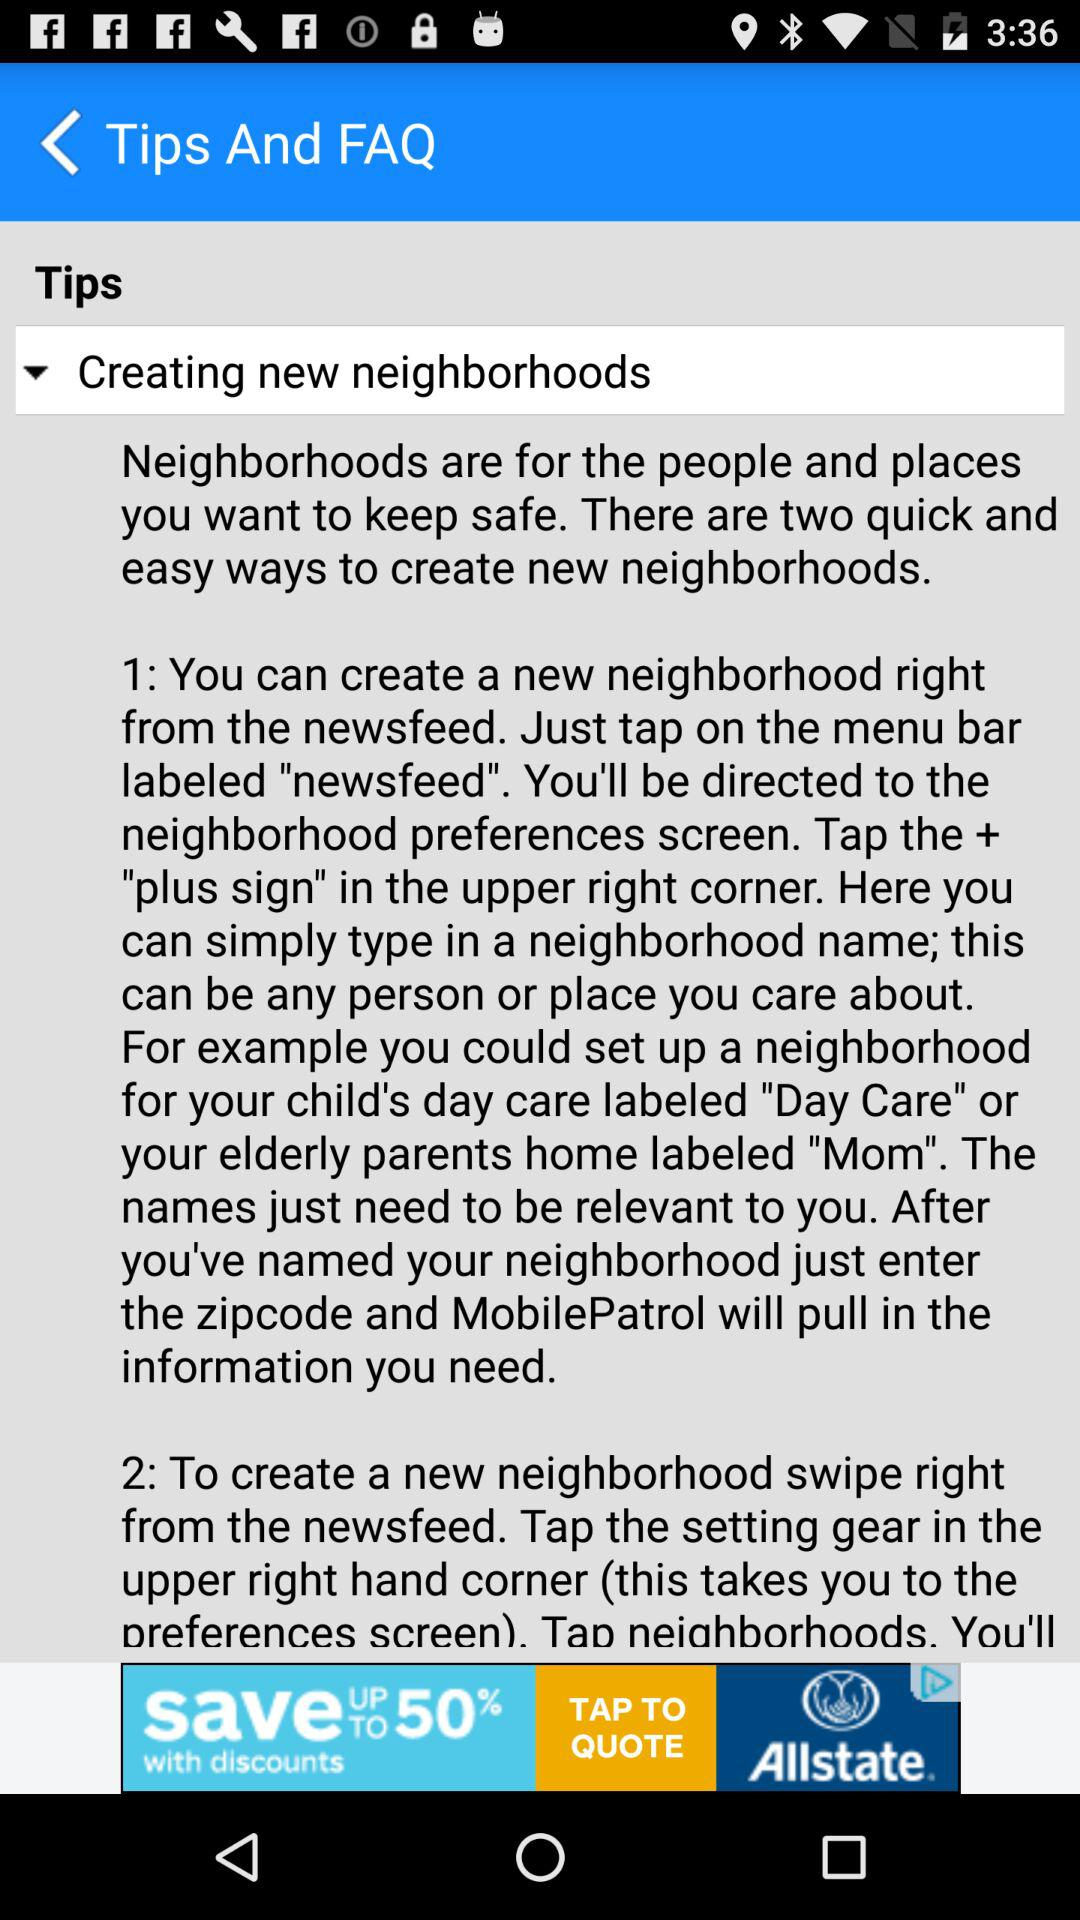How many ways are there to create a neighborhood?
Answer the question using a single word or phrase. 2 